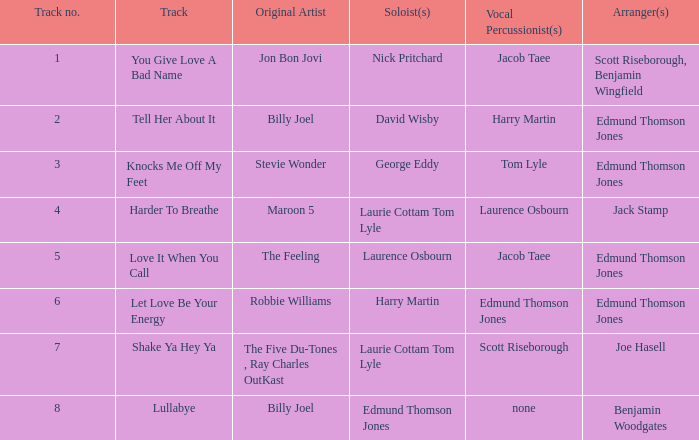Who were the original artist(s) on harder to breathe? Maroon 5. 